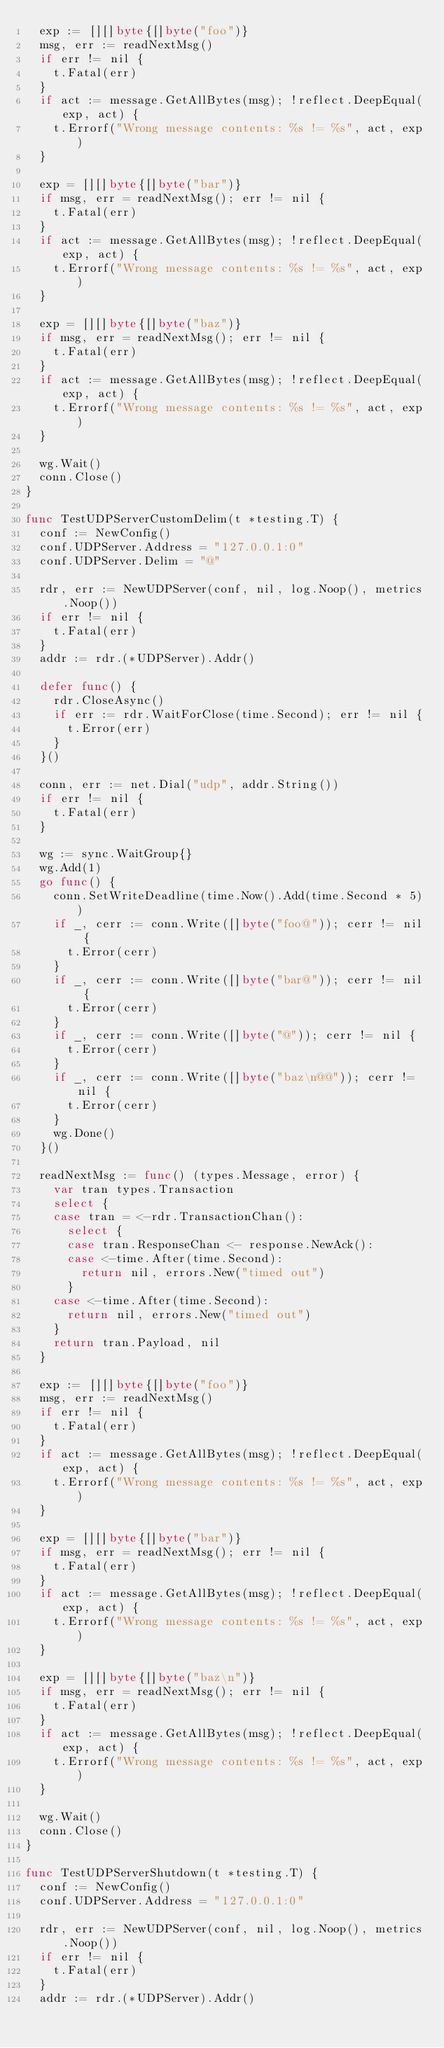Convert code to text. <code><loc_0><loc_0><loc_500><loc_500><_Go_>	exp := [][]byte{[]byte("foo")}
	msg, err := readNextMsg()
	if err != nil {
		t.Fatal(err)
	}
	if act := message.GetAllBytes(msg); !reflect.DeepEqual(exp, act) {
		t.Errorf("Wrong message contents: %s != %s", act, exp)
	}

	exp = [][]byte{[]byte("bar")}
	if msg, err = readNextMsg(); err != nil {
		t.Fatal(err)
	}
	if act := message.GetAllBytes(msg); !reflect.DeepEqual(exp, act) {
		t.Errorf("Wrong message contents: %s != %s", act, exp)
	}

	exp = [][]byte{[]byte("baz")}
	if msg, err = readNextMsg(); err != nil {
		t.Fatal(err)
	}
	if act := message.GetAllBytes(msg); !reflect.DeepEqual(exp, act) {
		t.Errorf("Wrong message contents: %s != %s", act, exp)
	}

	wg.Wait()
	conn.Close()
}

func TestUDPServerCustomDelim(t *testing.T) {
	conf := NewConfig()
	conf.UDPServer.Address = "127.0.0.1:0"
	conf.UDPServer.Delim = "@"

	rdr, err := NewUDPServer(conf, nil, log.Noop(), metrics.Noop())
	if err != nil {
		t.Fatal(err)
	}
	addr := rdr.(*UDPServer).Addr()

	defer func() {
		rdr.CloseAsync()
		if err := rdr.WaitForClose(time.Second); err != nil {
			t.Error(err)
		}
	}()

	conn, err := net.Dial("udp", addr.String())
	if err != nil {
		t.Fatal(err)
	}

	wg := sync.WaitGroup{}
	wg.Add(1)
	go func() {
		conn.SetWriteDeadline(time.Now().Add(time.Second * 5))
		if _, cerr := conn.Write([]byte("foo@")); cerr != nil {
			t.Error(cerr)
		}
		if _, cerr := conn.Write([]byte("bar@")); cerr != nil {
			t.Error(cerr)
		}
		if _, cerr := conn.Write([]byte("@")); cerr != nil {
			t.Error(cerr)
		}
		if _, cerr := conn.Write([]byte("baz\n@@")); cerr != nil {
			t.Error(cerr)
		}
		wg.Done()
	}()

	readNextMsg := func() (types.Message, error) {
		var tran types.Transaction
		select {
		case tran = <-rdr.TransactionChan():
			select {
			case tran.ResponseChan <- response.NewAck():
			case <-time.After(time.Second):
				return nil, errors.New("timed out")
			}
		case <-time.After(time.Second):
			return nil, errors.New("timed out")
		}
		return tran.Payload, nil
	}

	exp := [][]byte{[]byte("foo")}
	msg, err := readNextMsg()
	if err != nil {
		t.Fatal(err)
	}
	if act := message.GetAllBytes(msg); !reflect.DeepEqual(exp, act) {
		t.Errorf("Wrong message contents: %s != %s", act, exp)
	}

	exp = [][]byte{[]byte("bar")}
	if msg, err = readNextMsg(); err != nil {
		t.Fatal(err)
	}
	if act := message.GetAllBytes(msg); !reflect.DeepEqual(exp, act) {
		t.Errorf("Wrong message contents: %s != %s", act, exp)
	}

	exp = [][]byte{[]byte("baz\n")}
	if msg, err = readNextMsg(); err != nil {
		t.Fatal(err)
	}
	if act := message.GetAllBytes(msg); !reflect.DeepEqual(exp, act) {
		t.Errorf("Wrong message contents: %s != %s", act, exp)
	}

	wg.Wait()
	conn.Close()
}

func TestUDPServerShutdown(t *testing.T) {
	conf := NewConfig()
	conf.UDPServer.Address = "127.0.0.1:0"

	rdr, err := NewUDPServer(conf, nil, log.Noop(), metrics.Noop())
	if err != nil {
		t.Fatal(err)
	}
	addr := rdr.(*UDPServer).Addr()
</code> 